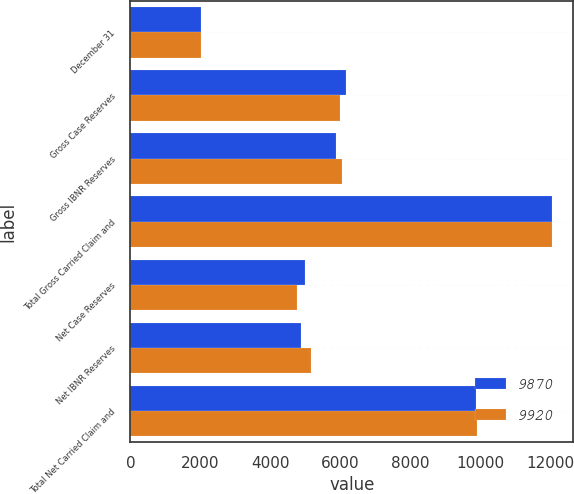Convert chart to OTSL. <chart><loc_0><loc_0><loc_500><loc_500><stacked_bar_chart><ecel><fcel>December 31<fcel>Gross Case Reserves<fcel>Gross IBNR Reserves<fcel>Total Gross Carried Claim and<fcel>Net Case Reserves<fcel>Net IBNR Reserves<fcel>Total Net Carried Claim and<nl><fcel>9870<fcel>2008<fcel>6158<fcel>5890<fcel>12048<fcel>4995<fcel>4875<fcel>9870<nl><fcel>9920<fcel>2007<fcel>5988<fcel>6060<fcel>12048<fcel>4750<fcel>5170<fcel>9920<nl></chart> 